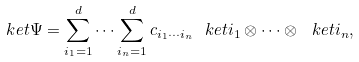Convert formula to latex. <formula><loc_0><loc_0><loc_500><loc_500>\ k e t { \Psi } = \sum _ { i _ { 1 } = 1 } ^ { d } \cdots \sum _ { i _ { n } = 1 } ^ { d } c _ { i _ { 1 } \cdots i _ { n } } \ k e t { i _ { 1 } } \otimes \cdots \otimes \ k e t { i _ { n } } ,</formula> 